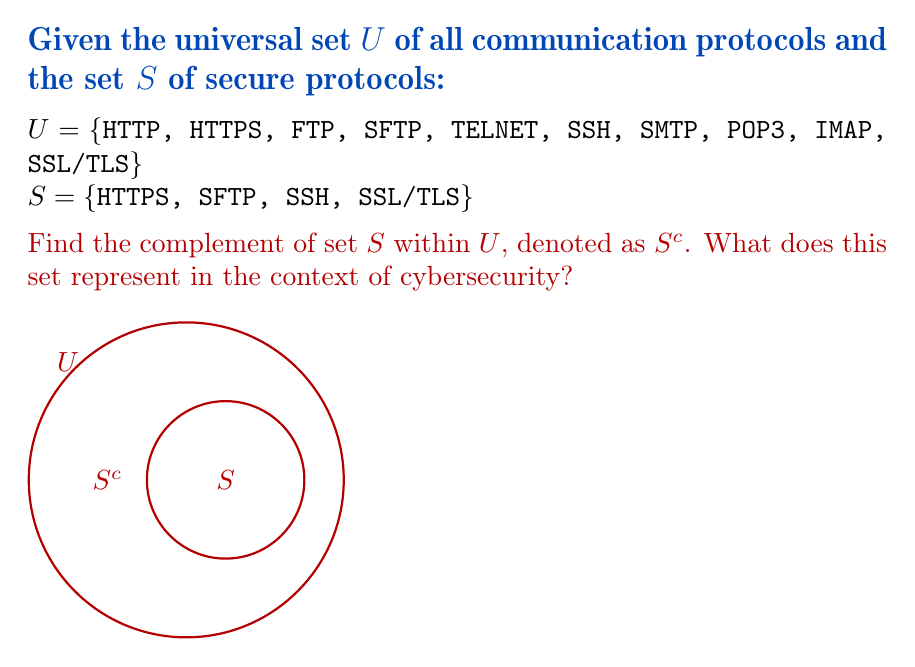Could you help me with this problem? To find the complement of set $S$ within the universal set $U$, we need to identify all elements in $U$ that are not in $S$. This can be represented mathematically as:

$$S^c = U \setminus S$$

Let's follow these steps:

1) List all elements in $U$:
   $U = \{HTTP, HTTPS, FTP, SFTP, TELNET, SSH, SMTP, POP3, IMAP, SSL/TLS\}$

2) List all elements in $S$:
   $S = \{HTTPS, SFTP, SSH, SSL/TLS\}$

3) Identify elements in $U$ that are not in $S$:
   $S^c = \{HTTP, FTP, TELNET, SMTP, POP3, IMAP\}$

In the context of cybersecurity, $S^c$ represents the set of insecure or potentially vulnerable communication protocols within the given universal set. These protocols do not inherently provide encryption or strong authentication mechanisms, making them susceptible to various cyber attacks such as eavesdropping, man-in-the-middle attacks, and data manipulation.

For an ardent cybersecurity student emphasizing the vulnerability of digital text storage, this set $S^c$ highlights the protocols that should be avoided or used with extreme caution when transmitting sensitive information. It underscores the importance of using secure protocols (represented by set $S$) to protect digital communications and stored data from potential threats.
Answer: $S^c = \{HTTP, FTP, TELNET, SMTP, POP3, IMAP\}$ 